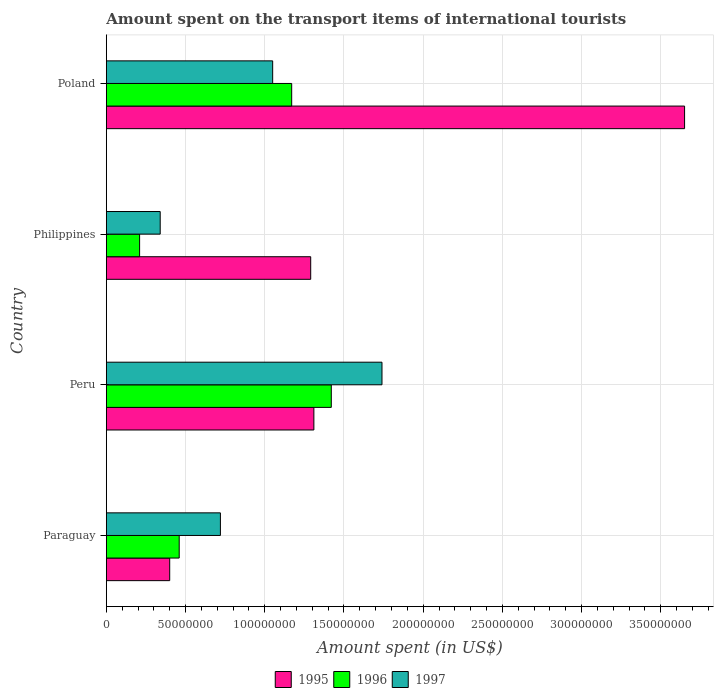Are the number of bars per tick equal to the number of legend labels?
Your response must be concise. Yes. Are the number of bars on each tick of the Y-axis equal?
Keep it short and to the point. Yes. How many bars are there on the 1st tick from the top?
Your answer should be compact. 3. What is the amount spent on the transport items of international tourists in 1997 in Peru?
Your response must be concise. 1.74e+08. Across all countries, what is the maximum amount spent on the transport items of international tourists in 1996?
Your answer should be very brief. 1.42e+08. Across all countries, what is the minimum amount spent on the transport items of international tourists in 1996?
Your response must be concise. 2.10e+07. In which country was the amount spent on the transport items of international tourists in 1995 maximum?
Make the answer very short. Poland. In which country was the amount spent on the transport items of international tourists in 1996 minimum?
Make the answer very short. Philippines. What is the total amount spent on the transport items of international tourists in 1997 in the graph?
Your response must be concise. 3.85e+08. What is the difference between the amount spent on the transport items of international tourists in 1996 in Paraguay and that in Poland?
Your answer should be very brief. -7.10e+07. What is the difference between the amount spent on the transport items of international tourists in 1997 in Poland and the amount spent on the transport items of international tourists in 1996 in Philippines?
Offer a terse response. 8.40e+07. What is the average amount spent on the transport items of international tourists in 1996 per country?
Your answer should be compact. 8.15e+07. What is the difference between the amount spent on the transport items of international tourists in 1996 and amount spent on the transport items of international tourists in 1995 in Peru?
Give a very brief answer. 1.10e+07. What is the ratio of the amount spent on the transport items of international tourists in 1995 in Paraguay to that in Philippines?
Offer a terse response. 0.31. Is the difference between the amount spent on the transport items of international tourists in 1996 in Paraguay and Peru greater than the difference between the amount spent on the transport items of international tourists in 1995 in Paraguay and Peru?
Keep it short and to the point. No. What is the difference between the highest and the second highest amount spent on the transport items of international tourists in 1995?
Offer a terse response. 2.34e+08. What is the difference between the highest and the lowest amount spent on the transport items of international tourists in 1997?
Your response must be concise. 1.40e+08. What does the 1st bar from the top in Poland represents?
Offer a very short reply. 1997. Is it the case that in every country, the sum of the amount spent on the transport items of international tourists in 1996 and amount spent on the transport items of international tourists in 1997 is greater than the amount spent on the transport items of international tourists in 1995?
Offer a terse response. No. How many bars are there?
Offer a terse response. 12. Are the values on the major ticks of X-axis written in scientific E-notation?
Give a very brief answer. No. Does the graph contain any zero values?
Keep it short and to the point. No. How many legend labels are there?
Offer a terse response. 3. How are the legend labels stacked?
Give a very brief answer. Horizontal. What is the title of the graph?
Provide a succinct answer. Amount spent on the transport items of international tourists. Does "2005" appear as one of the legend labels in the graph?
Ensure brevity in your answer.  No. What is the label or title of the X-axis?
Offer a very short reply. Amount spent (in US$). What is the label or title of the Y-axis?
Ensure brevity in your answer.  Country. What is the Amount spent (in US$) in 1995 in Paraguay?
Make the answer very short. 4.00e+07. What is the Amount spent (in US$) of 1996 in Paraguay?
Your answer should be very brief. 4.60e+07. What is the Amount spent (in US$) in 1997 in Paraguay?
Keep it short and to the point. 7.20e+07. What is the Amount spent (in US$) of 1995 in Peru?
Ensure brevity in your answer.  1.31e+08. What is the Amount spent (in US$) in 1996 in Peru?
Offer a very short reply. 1.42e+08. What is the Amount spent (in US$) of 1997 in Peru?
Your answer should be compact. 1.74e+08. What is the Amount spent (in US$) of 1995 in Philippines?
Your answer should be compact. 1.29e+08. What is the Amount spent (in US$) of 1996 in Philippines?
Ensure brevity in your answer.  2.10e+07. What is the Amount spent (in US$) of 1997 in Philippines?
Your answer should be compact. 3.40e+07. What is the Amount spent (in US$) in 1995 in Poland?
Give a very brief answer. 3.65e+08. What is the Amount spent (in US$) of 1996 in Poland?
Offer a terse response. 1.17e+08. What is the Amount spent (in US$) of 1997 in Poland?
Give a very brief answer. 1.05e+08. Across all countries, what is the maximum Amount spent (in US$) of 1995?
Give a very brief answer. 3.65e+08. Across all countries, what is the maximum Amount spent (in US$) of 1996?
Make the answer very short. 1.42e+08. Across all countries, what is the maximum Amount spent (in US$) in 1997?
Provide a short and direct response. 1.74e+08. Across all countries, what is the minimum Amount spent (in US$) of 1995?
Ensure brevity in your answer.  4.00e+07. Across all countries, what is the minimum Amount spent (in US$) in 1996?
Your response must be concise. 2.10e+07. Across all countries, what is the minimum Amount spent (in US$) of 1997?
Keep it short and to the point. 3.40e+07. What is the total Amount spent (in US$) in 1995 in the graph?
Offer a terse response. 6.65e+08. What is the total Amount spent (in US$) in 1996 in the graph?
Your response must be concise. 3.26e+08. What is the total Amount spent (in US$) of 1997 in the graph?
Give a very brief answer. 3.85e+08. What is the difference between the Amount spent (in US$) of 1995 in Paraguay and that in Peru?
Make the answer very short. -9.10e+07. What is the difference between the Amount spent (in US$) of 1996 in Paraguay and that in Peru?
Make the answer very short. -9.60e+07. What is the difference between the Amount spent (in US$) in 1997 in Paraguay and that in Peru?
Provide a succinct answer. -1.02e+08. What is the difference between the Amount spent (in US$) in 1995 in Paraguay and that in Philippines?
Your answer should be very brief. -8.90e+07. What is the difference between the Amount spent (in US$) in 1996 in Paraguay and that in Philippines?
Provide a succinct answer. 2.50e+07. What is the difference between the Amount spent (in US$) in 1997 in Paraguay and that in Philippines?
Your answer should be compact. 3.80e+07. What is the difference between the Amount spent (in US$) of 1995 in Paraguay and that in Poland?
Provide a short and direct response. -3.25e+08. What is the difference between the Amount spent (in US$) in 1996 in Paraguay and that in Poland?
Provide a short and direct response. -7.10e+07. What is the difference between the Amount spent (in US$) of 1997 in Paraguay and that in Poland?
Provide a short and direct response. -3.30e+07. What is the difference between the Amount spent (in US$) of 1996 in Peru and that in Philippines?
Ensure brevity in your answer.  1.21e+08. What is the difference between the Amount spent (in US$) of 1997 in Peru and that in Philippines?
Give a very brief answer. 1.40e+08. What is the difference between the Amount spent (in US$) in 1995 in Peru and that in Poland?
Ensure brevity in your answer.  -2.34e+08. What is the difference between the Amount spent (in US$) of 1996 in Peru and that in Poland?
Your response must be concise. 2.50e+07. What is the difference between the Amount spent (in US$) of 1997 in Peru and that in Poland?
Make the answer very short. 6.90e+07. What is the difference between the Amount spent (in US$) of 1995 in Philippines and that in Poland?
Your response must be concise. -2.36e+08. What is the difference between the Amount spent (in US$) of 1996 in Philippines and that in Poland?
Your response must be concise. -9.60e+07. What is the difference between the Amount spent (in US$) in 1997 in Philippines and that in Poland?
Give a very brief answer. -7.10e+07. What is the difference between the Amount spent (in US$) of 1995 in Paraguay and the Amount spent (in US$) of 1996 in Peru?
Your answer should be compact. -1.02e+08. What is the difference between the Amount spent (in US$) in 1995 in Paraguay and the Amount spent (in US$) in 1997 in Peru?
Offer a very short reply. -1.34e+08. What is the difference between the Amount spent (in US$) in 1996 in Paraguay and the Amount spent (in US$) in 1997 in Peru?
Your response must be concise. -1.28e+08. What is the difference between the Amount spent (in US$) of 1995 in Paraguay and the Amount spent (in US$) of 1996 in Philippines?
Make the answer very short. 1.90e+07. What is the difference between the Amount spent (in US$) of 1995 in Paraguay and the Amount spent (in US$) of 1997 in Philippines?
Offer a terse response. 6.00e+06. What is the difference between the Amount spent (in US$) of 1996 in Paraguay and the Amount spent (in US$) of 1997 in Philippines?
Keep it short and to the point. 1.20e+07. What is the difference between the Amount spent (in US$) in 1995 in Paraguay and the Amount spent (in US$) in 1996 in Poland?
Make the answer very short. -7.70e+07. What is the difference between the Amount spent (in US$) in 1995 in Paraguay and the Amount spent (in US$) in 1997 in Poland?
Offer a terse response. -6.50e+07. What is the difference between the Amount spent (in US$) of 1996 in Paraguay and the Amount spent (in US$) of 1997 in Poland?
Provide a succinct answer. -5.90e+07. What is the difference between the Amount spent (in US$) in 1995 in Peru and the Amount spent (in US$) in 1996 in Philippines?
Your answer should be compact. 1.10e+08. What is the difference between the Amount spent (in US$) of 1995 in Peru and the Amount spent (in US$) of 1997 in Philippines?
Provide a short and direct response. 9.70e+07. What is the difference between the Amount spent (in US$) in 1996 in Peru and the Amount spent (in US$) in 1997 in Philippines?
Give a very brief answer. 1.08e+08. What is the difference between the Amount spent (in US$) in 1995 in Peru and the Amount spent (in US$) in 1996 in Poland?
Your answer should be very brief. 1.40e+07. What is the difference between the Amount spent (in US$) in 1995 in Peru and the Amount spent (in US$) in 1997 in Poland?
Ensure brevity in your answer.  2.60e+07. What is the difference between the Amount spent (in US$) in 1996 in Peru and the Amount spent (in US$) in 1997 in Poland?
Provide a short and direct response. 3.70e+07. What is the difference between the Amount spent (in US$) of 1995 in Philippines and the Amount spent (in US$) of 1996 in Poland?
Ensure brevity in your answer.  1.20e+07. What is the difference between the Amount spent (in US$) of 1995 in Philippines and the Amount spent (in US$) of 1997 in Poland?
Ensure brevity in your answer.  2.40e+07. What is the difference between the Amount spent (in US$) in 1996 in Philippines and the Amount spent (in US$) in 1997 in Poland?
Your response must be concise. -8.40e+07. What is the average Amount spent (in US$) in 1995 per country?
Ensure brevity in your answer.  1.66e+08. What is the average Amount spent (in US$) in 1996 per country?
Make the answer very short. 8.15e+07. What is the average Amount spent (in US$) of 1997 per country?
Your answer should be very brief. 9.62e+07. What is the difference between the Amount spent (in US$) in 1995 and Amount spent (in US$) in 1996 in Paraguay?
Ensure brevity in your answer.  -6.00e+06. What is the difference between the Amount spent (in US$) of 1995 and Amount spent (in US$) of 1997 in Paraguay?
Offer a very short reply. -3.20e+07. What is the difference between the Amount spent (in US$) in 1996 and Amount spent (in US$) in 1997 in Paraguay?
Provide a succinct answer. -2.60e+07. What is the difference between the Amount spent (in US$) of 1995 and Amount spent (in US$) of 1996 in Peru?
Make the answer very short. -1.10e+07. What is the difference between the Amount spent (in US$) of 1995 and Amount spent (in US$) of 1997 in Peru?
Offer a terse response. -4.30e+07. What is the difference between the Amount spent (in US$) of 1996 and Amount spent (in US$) of 1997 in Peru?
Make the answer very short. -3.20e+07. What is the difference between the Amount spent (in US$) of 1995 and Amount spent (in US$) of 1996 in Philippines?
Offer a very short reply. 1.08e+08. What is the difference between the Amount spent (in US$) of 1995 and Amount spent (in US$) of 1997 in Philippines?
Provide a short and direct response. 9.50e+07. What is the difference between the Amount spent (in US$) of 1996 and Amount spent (in US$) of 1997 in Philippines?
Your answer should be compact. -1.30e+07. What is the difference between the Amount spent (in US$) in 1995 and Amount spent (in US$) in 1996 in Poland?
Provide a succinct answer. 2.48e+08. What is the difference between the Amount spent (in US$) of 1995 and Amount spent (in US$) of 1997 in Poland?
Give a very brief answer. 2.60e+08. What is the difference between the Amount spent (in US$) of 1996 and Amount spent (in US$) of 1997 in Poland?
Offer a terse response. 1.20e+07. What is the ratio of the Amount spent (in US$) of 1995 in Paraguay to that in Peru?
Keep it short and to the point. 0.31. What is the ratio of the Amount spent (in US$) of 1996 in Paraguay to that in Peru?
Provide a succinct answer. 0.32. What is the ratio of the Amount spent (in US$) of 1997 in Paraguay to that in Peru?
Offer a terse response. 0.41. What is the ratio of the Amount spent (in US$) of 1995 in Paraguay to that in Philippines?
Offer a very short reply. 0.31. What is the ratio of the Amount spent (in US$) in 1996 in Paraguay to that in Philippines?
Provide a short and direct response. 2.19. What is the ratio of the Amount spent (in US$) in 1997 in Paraguay to that in Philippines?
Keep it short and to the point. 2.12. What is the ratio of the Amount spent (in US$) of 1995 in Paraguay to that in Poland?
Ensure brevity in your answer.  0.11. What is the ratio of the Amount spent (in US$) in 1996 in Paraguay to that in Poland?
Keep it short and to the point. 0.39. What is the ratio of the Amount spent (in US$) in 1997 in Paraguay to that in Poland?
Give a very brief answer. 0.69. What is the ratio of the Amount spent (in US$) of 1995 in Peru to that in Philippines?
Offer a terse response. 1.02. What is the ratio of the Amount spent (in US$) of 1996 in Peru to that in Philippines?
Your response must be concise. 6.76. What is the ratio of the Amount spent (in US$) in 1997 in Peru to that in Philippines?
Your answer should be compact. 5.12. What is the ratio of the Amount spent (in US$) in 1995 in Peru to that in Poland?
Make the answer very short. 0.36. What is the ratio of the Amount spent (in US$) of 1996 in Peru to that in Poland?
Make the answer very short. 1.21. What is the ratio of the Amount spent (in US$) in 1997 in Peru to that in Poland?
Keep it short and to the point. 1.66. What is the ratio of the Amount spent (in US$) in 1995 in Philippines to that in Poland?
Make the answer very short. 0.35. What is the ratio of the Amount spent (in US$) in 1996 in Philippines to that in Poland?
Give a very brief answer. 0.18. What is the ratio of the Amount spent (in US$) of 1997 in Philippines to that in Poland?
Give a very brief answer. 0.32. What is the difference between the highest and the second highest Amount spent (in US$) of 1995?
Make the answer very short. 2.34e+08. What is the difference between the highest and the second highest Amount spent (in US$) of 1996?
Give a very brief answer. 2.50e+07. What is the difference between the highest and the second highest Amount spent (in US$) in 1997?
Provide a short and direct response. 6.90e+07. What is the difference between the highest and the lowest Amount spent (in US$) in 1995?
Offer a very short reply. 3.25e+08. What is the difference between the highest and the lowest Amount spent (in US$) of 1996?
Keep it short and to the point. 1.21e+08. What is the difference between the highest and the lowest Amount spent (in US$) in 1997?
Provide a short and direct response. 1.40e+08. 